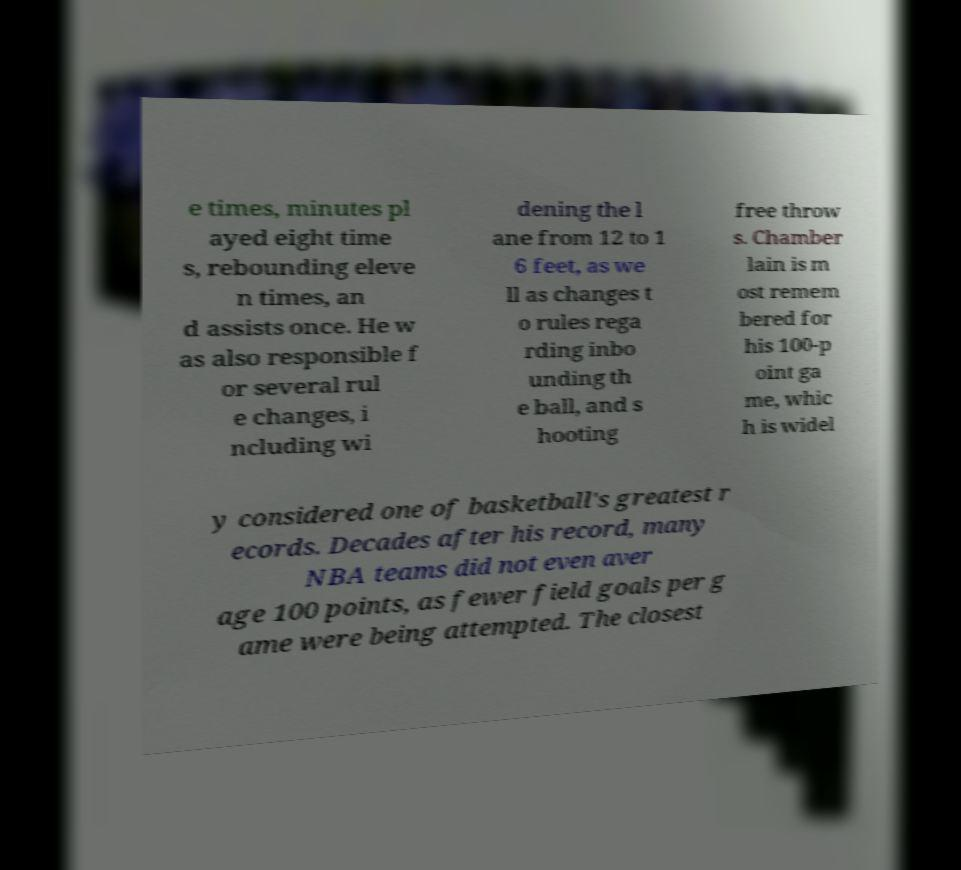I need the written content from this picture converted into text. Can you do that? e times, minutes pl ayed eight time s, rebounding eleve n times, an d assists once. He w as also responsible f or several rul e changes, i ncluding wi dening the l ane from 12 to 1 6 feet, as we ll as changes t o rules rega rding inbo unding th e ball, and s hooting free throw s. Chamber lain is m ost remem bered for his 100-p oint ga me, whic h is widel y considered one of basketball's greatest r ecords. Decades after his record, many NBA teams did not even aver age 100 points, as fewer field goals per g ame were being attempted. The closest 